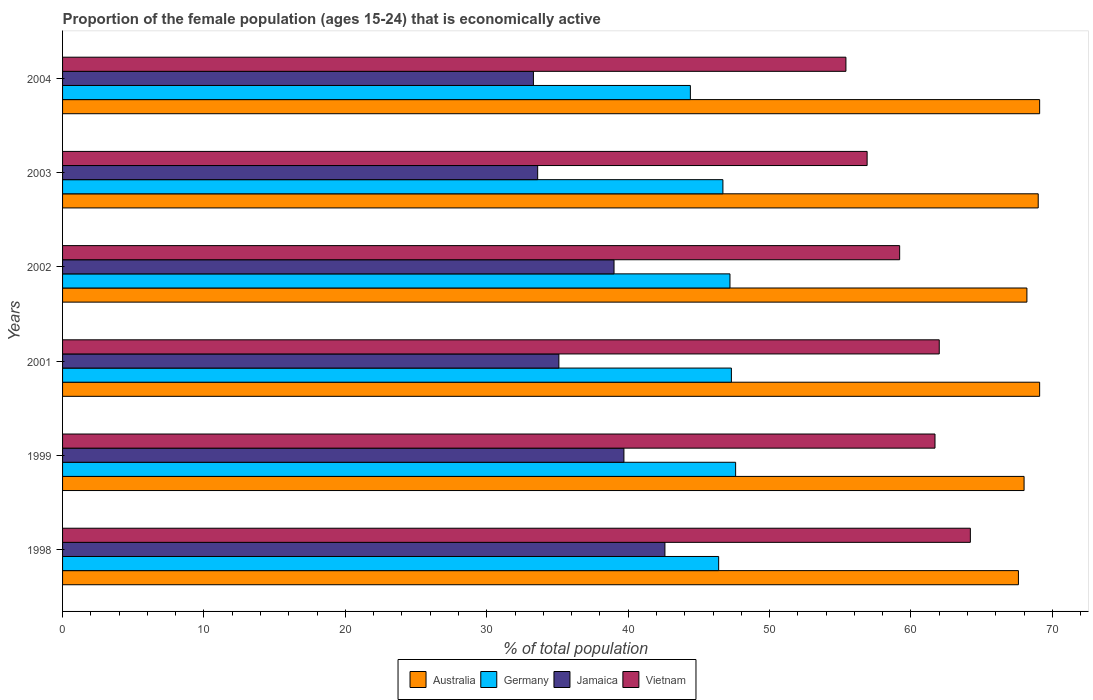How many different coloured bars are there?
Offer a very short reply. 4. How many groups of bars are there?
Your response must be concise. 6. Are the number of bars per tick equal to the number of legend labels?
Make the answer very short. Yes. Are the number of bars on each tick of the Y-axis equal?
Your response must be concise. Yes. How many bars are there on the 6th tick from the bottom?
Provide a short and direct response. 4. What is the proportion of the female population that is economically active in Australia in 2004?
Give a very brief answer. 69.1. Across all years, what is the maximum proportion of the female population that is economically active in Australia?
Your answer should be compact. 69.1. Across all years, what is the minimum proportion of the female population that is economically active in Australia?
Your response must be concise. 67.6. In which year was the proportion of the female population that is economically active in Germany maximum?
Offer a very short reply. 1999. In which year was the proportion of the female population that is economically active in Jamaica minimum?
Make the answer very short. 2004. What is the total proportion of the female population that is economically active in Jamaica in the graph?
Your answer should be very brief. 223.3. What is the difference between the proportion of the female population that is economically active in Vietnam in 1998 and the proportion of the female population that is economically active in Australia in 2001?
Make the answer very short. -4.9. What is the average proportion of the female population that is economically active in Australia per year?
Your answer should be very brief. 68.5. In the year 2003, what is the difference between the proportion of the female population that is economically active in Germany and proportion of the female population that is economically active in Vietnam?
Your answer should be compact. -10.2. What is the ratio of the proportion of the female population that is economically active in Germany in 1998 to that in 2003?
Offer a very short reply. 0.99. Is the proportion of the female population that is economically active in Vietnam in 1999 less than that in 2001?
Your answer should be very brief. Yes. Is the difference between the proportion of the female population that is economically active in Germany in 2001 and 2004 greater than the difference between the proportion of the female population that is economically active in Vietnam in 2001 and 2004?
Provide a short and direct response. No. What is the difference between the highest and the second highest proportion of the female population that is economically active in Vietnam?
Keep it short and to the point. 2.2. What is the difference between the highest and the lowest proportion of the female population that is economically active in Vietnam?
Offer a terse response. 8.8. In how many years, is the proportion of the female population that is economically active in Vietnam greater than the average proportion of the female population that is economically active in Vietnam taken over all years?
Your answer should be very brief. 3. Is the sum of the proportion of the female population that is economically active in Australia in 2001 and 2004 greater than the maximum proportion of the female population that is economically active in Jamaica across all years?
Your answer should be very brief. Yes. What does the 3rd bar from the top in 1999 represents?
Keep it short and to the point. Germany. Are all the bars in the graph horizontal?
Ensure brevity in your answer.  Yes. How many years are there in the graph?
Provide a short and direct response. 6. Does the graph contain any zero values?
Your answer should be compact. No. Does the graph contain grids?
Offer a very short reply. No. How are the legend labels stacked?
Give a very brief answer. Horizontal. What is the title of the graph?
Make the answer very short. Proportion of the female population (ages 15-24) that is economically active. What is the label or title of the X-axis?
Give a very brief answer. % of total population. What is the % of total population of Australia in 1998?
Offer a terse response. 67.6. What is the % of total population in Germany in 1998?
Offer a very short reply. 46.4. What is the % of total population in Jamaica in 1998?
Provide a short and direct response. 42.6. What is the % of total population in Vietnam in 1998?
Provide a succinct answer. 64.2. What is the % of total population of Australia in 1999?
Your answer should be very brief. 68. What is the % of total population in Germany in 1999?
Offer a very short reply. 47.6. What is the % of total population of Jamaica in 1999?
Ensure brevity in your answer.  39.7. What is the % of total population of Vietnam in 1999?
Your answer should be compact. 61.7. What is the % of total population of Australia in 2001?
Offer a very short reply. 69.1. What is the % of total population in Germany in 2001?
Offer a terse response. 47.3. What is the % of total population in Jamaica in 2001?
Keep it short and to the point. 35.1. What is the % of total population in Vietnam in 2001?
Provide a succinct answer. 62. What is the % of total population of Australia in 2002?
Ensure brevity in your answer.  68.2. What is the % of total population of Germany in 2002?
Keep it short and to the point. 47.2. What is the % of total population in Jamaica in 2002?
Give a very brief answer. 39. What is the % of total population in Vietnam in 2002?
Your answer should be very brief. 59.2. What is the % of total population in Australia in 2003?
Ensure brevity in your answer.  69. What is the % of total population of Germany in 2003?
Your answer should be very brief. 46.7. What is the % of total population of Jamaica in 2003?
Your answer should be compact. 33.6. What is the % of total population in Vietnam in 2003?
Ensure brevity in your answer.  56.9. What is the % of total population in Australia in 2004?
Offer a terse response. 69.1. What is the % of total population of Germany in 2004?
Provide a succinct answer. 44.4. What is the % of total population in Jamaica in 2004?
Offer a very short reply. 33.3. What is the % of total population in Vietnam in 2004?
Make the answer very short. 55.4. Across all years, what is the maximum % of total population in Australia?
Make the answer very short. 69.1. Across all years, what is the maximum % of total population in Germany?
Offer a terse response. 47.6. Across all years, what is the maximum % of total population in Jamaica?
Offer a very short reply. 42.6. Across all years, what is the maximum % of total population of Vietnam?
Your answer should be compact. 64.2. Across all years, what is the minimum % of total population of Australia?
Make the answer very short. 67.6. Across all years, what is the minimum % of total population in Germany?
Make the answer very short. 44.4. Across all years, what is the minimum % of total population of Jamaica?
Ensure brevity in your answer.  33.3. Across all years, what is the minimum % of total population of Vietnam?
Your answer should be very brief. 55.4. What is the total % of total population in Australia in the graph?
Offer a terse response. 411. What is the total % of total population in Germany in the graph?
Provide a short and direct response. 279.6. What is the total % of total population of Jamaica in the graph?
Make the answer very short. 223.3. What is the total % of total population of Vietnam in the graph?
Your response must be concise. 359.4. What is the difference between the % of total population of Germany in 1998 and that in 1999?
Provide a short and direct response. -1.2. What is the difference between the % of total population of Jamaica in 1998 and that in 1999?
Your answer should be compact. 2.9. What is the difference between the % of total population in Australia in 1998 and that in 2002?
Offer a very short reply. -0.6. What is the difference between the % of total population in Germany in 1998 and that in 2002?
Your response must be concise. -0.8. What is the difference between the % of total population in Jamaica in 1998 and that in 2002?
Make the answer very short. 3.6. What is the difference between the % of total population of Germany in 1998 and that in 2003?
Provide a short and direct response. -0.3. What is the difference between the % of total population of Germany in 1998 and that in 2004?
Offer a terse response. 2. What is the difference between the % of total population of Jamaica in 1998 and that in 2004?
Offer a very short reply. 9.3. What is the difference between the % of total population of Australia in 1999 and that in 2001?
Make the answer very short. -1.1. What is the difference between the % of total population in Jamaica in 1999 and that in 2001?
Keep it short and to the point. 4.6. What is the difference between the % of total population in Vietnam in 1999 and that in 2001?
Offer a very short reply. -0.3. What is the difference between the % of total population of Australia in 1999 and that in 2002?
Your response must be concise. -0.2. What is the difference between the % of total population in Jamaica in 1999 and that in 2002?
Your answer should be very brief. 0.7. What is the difference between the % of total population in Vietnam in 1999 and that in 2002?
Your answer should be compact. 2.5. What is the difference between the % of total population of Australia in 1999 and that in 2003?
Provide a succinct answer. -1. What is the difference between the % of total population in Germany in 1999 and that in 2003?
Provide a short and direct response. 0.9. What is the difference between the % of total population of Jamaica in 1999 and that in 2003?
Offer a terse response. 6.1. What is the difference between the % of total population of Australia in 1999 and that in 2004?
Your answer should be compact. -1.1. What is the difference between the % of total population of Germany in 1999 and that in 2004?
Offer a terse response. 3.2. What is the difference between the % of total population of Jamaica in 1999 and that in 2004?
Your response must be concise. 6.4. What is the difference between the % of total population of Jamaica in 2001 and that in 2002?
Your response must be concise. -3.9. What is the difference between the % of total population of Vietnam in 2001 and that in 2002?
Offer a very short reply. 2.8. What is the difference between the % of total population of Germany in 2001 and that in 2003?
Your answer should be very brief. 0.6. What is the difference between the % of total population in Jamaica in 2001 and that in 2003?
Offer a terse response. 1.5. What is the difference between the % of total population in Australia in 2001 and that in 2004?
Offer a terse response. 0. What is the difference between the % of total population in Germany in 2001 and that in 2004?
Make the answer very short. 2.9. What is the difference between the % of total population in Jamaica in 2001 and that in 2004?
Ensure brevity in your answer.  1.8. What is the difference between the % of total population in Vietnam in 2001 and that in 2004?
Give a very brief answer. 6.6. What is the difference between the % of total population of Australia in 2002 and that in 2003?
Offer a terse response. -0.8. What is the difference between the % of total population in Germany in 2002 and that in 2003?
Provide a succinct answer. 0.5. What is the difference between the % of total population in Jamaica in 2002 and that in 2003?
Your response must be concise. 5.4. What is the difference between the % of total population of Australia in 2002 and that in 2004?
Offer a very short reply. -0.9. What is the difference between the % of total population of Australia in 2003 and that in 2004?
Offer a terse response. -0.1. What is the difference between the % of total population in Jamaica in 2003 and that in 2004?
Provide a succinct answer. 0.3. What is the difference between the % of total population of Vietnam in 2003 and that in 2004?
Ensure brevity in your answer.  1.5. What is the difference between the % of total population in Australia in 1998 and the % of total population in Germany in 1999?
Keep it short and to the point. 20. What is the difference between the % of total population of Australia in 1998 and the % of total population of Jamaica in 1999?
Make the answer very short. 27.9. What is the difference between the % of total population of Germany in 1998 and the % of total population of Vietnam in 1999?
Provide a succinct answer. -15.3. What is the difference between the % of total population in Jamaica in 1998 and the % of total population in Vietnam in 1999?
Offer a terse response. -19.1. What is the difference between the % of total population in Australia in 1998 and the % of total population in Germany in 2001?
Keep it short and to the point. 20.3. What is the difference between the % of total population in Australia in 1998 and the % of total population in Jamaica in 2001?
Your answer should be very brief. 32.5. What is the difference between the % of total population in Germany in 1998 and the % of total population in Jamaica in 2001?
Offer a very short reply. 11.3. What is the difference between the % of total population of Germany in 1998 and the % of total population of Vietnam in 2001?
Provide a short and direct response. -15.6. What is the difference between the % of total population of Jamaica in 1998 and the % of total population of Vietnam in 2001?
Provide a short and direct response. -19.4. What is the difference between the % of total population in Australia in 1998 and the % of total population in Germany in 2002?
Give a very brief answer. 20.4. What is the difference between the % of total population of Australia in 1998 and the % of total population of Jamaica in 2002?
Provide a short and direct response. 28.6. What is the difference between the % of total population of Australia in 1998 and the % of total population of Vietnam in 2002?
Offer a very short reply. 8.4. What is the difference between the % of total population of Germany in 1998 and the % of total population of Jamaica in 2002?
Your answer should be compact. 7.4. What is the difference between the % of total population of Jamaica in 1998 and the % of total population of Vietnam in 2002?
Your response must be concise. -16.6. What is the difference between the % of total population in Australia in 1998 and the % of total population in Germany in 2003?
Give a very brief answer. 20.9. What is the difference between the % of total population in Australia in 1998 and the % of total population in Jamaica in 2003?
Offer a terse response. 34. What is the difference between the % of total population in Germany in 1998 and the % of total population in Jamaica in 2003?
Give a very brief answer. 12.8. What is the difference between the % of total population in Jamaica in 1998 and the % of total population in Vietnam in 2003?
Ensure brevity in your answer.  -14.3. What is the difference between the % of total population of Australia in 1998 and the % of total population of Germany in 2004?
Offer a very short reply. 23.2. What is the difference between the % of total population of Australia in 1998 and the % of total population of Jamaica in 2004?
Keep it short and to the point. 34.3. What is the difference between the % of total population of Australia in 1998 and the % of total population of Vietnam in 2004?
Offer a very short reply. 12.2. What is the difference between the % of total population of Jamaica in 1998 and the % of total population of Vietnam in 2004?
Your response must be concise. -12.8. What is the difference between the % of total population of Australia in 1999 and the % of total population of Germany in 2001?
Keep it short and to the point. 20.7. What is the difference between the % of total population of Australia in 1999 and the % of total population of Jamaica in 2001?
Offer a very short reply. 32.9. What is the difference between the % of total population of Germany in 1999 and the % of total population of Vietnam in 2001?
Your response must be concise. -14.4. What is the difference between the % of total population of Jamaica in 1999 and the % of total population of Vietnam in 2001?
Keep it short and to the point. -22.3. What is the difference between the % of total population in Australia in 1999 and the % of total population in Germany in 2002?
Provide a succinct answer. 20.8. What is the difference between the % of total population of Australia in 1999 and the % of total population of Jamaica in 2002?
Keep it short and to the point. 29. What is the difference between the % of total population of Australia in 1999 and the % of total population of Vietnam in 2002?
Your answer should be compact. 8.8. What is the difference between the % of total population in Germany in 1999 and the % of total population in Jamaica in 2002?
Provide a succinct answer. 8.6. What is the difference between the % of total population of Germany in 1999 and the % of total population of Vietnam in 2002?
Provide a short and direct response. -11.6. What is the difference between the % of total population in Jamaica in 1999 and the % of total population in Vietnam in 2002?
Keep it short and to the point. -19.5. What is the difference between the % of total population of Australia in 1999 and the % of total population of Germany in 2003?
Offer a very short reply. 21.3. What is the difference between the % of total population in Australia in 1999 and the % of total population in Jamaica in 2003?
Ensure brevity in your answer.  34.4. What is the difference between the % of total population of Germany in 1999 and the % of total population of Jamaica in 2003?
Provide a short and direct response. 14. What is the difference between the % of total population of Jamaica in 1999 and the % of total population of Vietnam in 2003?
Provide a succinct answer. -17.2. What is the difference between the % of total population in Australia in 1999 and the % of total population in Germany in 2004?
Ensure brevity in your answer.  23.6. What is the difference between the % of total population in Australia in 1999 and the % of total population in Jamaica in 2004?
Your answer should be compact. 34.7. What is the difference between the % of total population of Australia in 1999 and the % of total population of Vietnam in 2004?
Your answer should be compact. 12.6. What is the difference between the % of total population of Germany in 1999 and the % of total population of Jamaica in 2004?
Your answer should be very brief. 14.3. What is the difference between the % of total population of Germany in 1999 and the % of total population of Vietnam in 2004?
Keep it short and to the point. -7.8. What is the difference between the % of total population of Jamaica in 1999 and the % of total population of Vietnam in 2004?
Give a very brief answer. -15.7. What is the difference between the % of total population of Australia in 2001 and the % of total population of Germany in 2002?
Your response must be concise. 21.9. What is the difference between the % of total population of Australia in 2001 and the % of total population of Jamaica in 2002?
Give a very brief answer. 30.1. What is the difference between the % of total population in Australia in 2001 and the % of total population in Vietnam in 2002?
Offer a terse response. 9.9. What is the difference between the % of total population of Germany in 2001 and the % of total population of Jamaica in 2002?
Provide a short and direct response. 8.3. What is the difference between the % of total population of Germany in 2001 and the % of total population of Vietnam in 2002?
Provide a short and direct response. -11.9. What is the difference between the % of total population in Jamaica in 2001 and the % of total population in Vietnam in 2002?
Offer a very short reply. -24.1. What is the difference between the % of total population in Australia in 2001 and the % of total population in Germany in 2003?
Give a very brief answer. 22.4. What is the difference between the % of total population in Australia in 2001 and the % of total population in Jamaica in 2003?
Give a very brief answer. 35.5. What is the difference between the % of total population of Jamaica in 2001 and the % of total population of Vietnam in 2003?
Your answer should be compact. -21.8. What is the difference between the % of total population of Australia in 2001 and the % of total population of Germany in 2004?
Your answer should be compact. 24.7. What is the difference between the % of total population in Australia in 2001 and the % of total population in Jamaica in 2004?
Provide a succinct answer. 35.8. What is the difference between the % of total population of Germany in 2001 and the % of total population of Jamaica in 2004?
Keep it short and to the point. 14. What is the difference between the % of total population in Jamaica in 2001 and the % of total population in Vietnam in 2004?
Offer a very short reply. -20.3. What is the difference between the % of total population of Australia in 2002 and the % of total population of Germany in 2003?
Make the answer very short. 21.5. What is the difference between the % of total population in Australia in 2002 and the % of total population in Jamaica in 2003?
Your answer should be very brief. 34.6. What is the difference between the % of total population of Australia in 2002 and the % of total population of Vietnam in 2003?
Offer a terse response. 11.3. What is the difference between the % of total population of Germany in 2002 and the % of total population of Vietnam in 2003?
Give a very brief answer. -9.7. What is the difference between the % of total population in Jamaica in 2002 and the % of total population in Vietnam in 2003?
Ensure brevity in your answer.  -17.9. What is the difference between the % of total population in Australia in 2002 and the % of total population in Germany in 2004?
Your answer should be compact. 23.8. What is the difference between the % of total population in Australia in 2002 and the % of total population in Jamaica in 2004?
Provide a succinct answer. 34.9. What is the difference between the % of total population of Germany in 2002 and the % of total population of Vietnam in 2004?
Offer a very short reply. -8.2. What is the difference between the % of total population in Jamaica in 2002 and the % of total population in Vietnam in 2004?
Provide a succinct answer. -16.4. What is the difference between the % of total population in Australia in 2003 and the % of total population in Germany in 2004?
Offer a terse response. 24.6. What is the difference between the % of total population in Australia in 2003 and the % of total population in Jamaica in 2004?
Make the answer very short. 35.7. What is the difference between the % of total population of Australia in 2003 and the % of total population of Vietnam in 2004?
Ensure brevity in your answer.  13.6. What is the difference between the % of total population in Germany in 2003 and the % of total population in Jamaica in 2004?
Your answer should be very brief. 13.4. What is the difference between the % of total population in Jamaica in 2003 and the % of total population in Vietnam in 2004?
Make the answer very short. -21.8. What is the average % of total population of Australia per year?
Provide a succinct answer. 68.5. What is the average % of total population of Germany per year?
Your answer should be very brief. 46.6. What is the average % of total population in Jamaica per year?
Your response must be concise. 37.22. What is the average % of total population of Vietnam per year?
Provide a short and direct response. 59.9. In the year 1998, what is the difference between the % of total population of Australia and % of total population of Germany?
Ensure brevity in your answer.  21.2. In the year 1998, what is the difference between the % of total population in Australia and % of total population in Vietnam?
Offer a very short reply. 3.4. In the year 1998, what is the difference between the % of total population of Germany and % of total population of Jamaica?
Your response must be concise. 3.8. In the year 1998, what is the difference between the % of total population of Germany and % of total population of Vietnam?
Ensure brevity in your answer.  -17.8. In the year 1998, what is the difference between the % of total population in Jamaica and % of total population in Vietnam?
Give a very brief answer. -21.6. In the year 1999, what is the difference between the % of total population in Australia and % of total population in Germany?
Offer a terse response. 20.4. In the year 1999, what is the difference between the % of total population in Australia and % of total population in Jamaica?
Offer a terse response. 28.3. In the year 1999, what is the difference between the % of total population of Australia and % of total population of Vietnam?
Provide a succinct answer. 6.3. In the year 1999, what is the difference between the % of total population in Germany and % of total population in Jamaica?
Your response must be concise. 7.9. In the year 1999, what is the difference between the % of total population in Germany and % of total population in Vietnam?
Offer a terse response. -14.1. In the year 1999, what is the difference between the % of total population of Jamaica and % of total population of Vietnam?
Provide a succinct answer. -22. In the year 2001, what is the difference between the % of total population in Australia and % of total population in Germany?
Offer a terse response. 21.8. In the year 2001, what is the difference between the % of total population of Germany and % of total population of Jamaica?
Ensure brevity in your answer.  12.2. In the year 2001, what is the difference between the % of total population of Germany and % of total population of Vietnam?
Keep it short and to the point. -14.7. In the year 2001, what is the difference between the % of total population in Jamaica and % of total population in Vietnam?
Your answer should be very brief. -26.9. In the year 2002, what is the difference between the % of total population in Australia and % of total population in Germany?
Ensure brevity in your answer.  21. In the year 2002, what is the difference between the % of total population of Australia and % of total population of Jamaica?
Offer a terse response. 29.2. In the year 2002, what is the difference between the % of total population of Australia and % of total population of Vietnam?
Provide a succinct answer. 9. In the year 2002, what is the difference between the % of total population in Germany and % of total population in Vietnam?
Provide a short and direct response. -12. In the year 2002, what is the difference between the % of total population of Jamaica and % of total population of Vietnam?
Your answer should be very brief. -20.2. In the year 2003, what is the difference between the % of total population of Australia and % of total population of Germany?
Ensure brevity in your answer.  22.3. In the year 2003, what is the difference between the % of total population in Australia and % of total population in Jamaica?
Provide a succinct answer. 35.4. In the year 2003, what is the difference between the % of total population of Germany and % of total population of Jamaica?
Your response must be concise. 13.1. In the year 2003, what is the difference between the % of total population in Germany and % of total population in Vietnam?
Your answer should be very brief. -10.2. In the year 2003, what is the difference between the % of total population of Jamaica and % of total population of Vietnam?
Offer a terse response. -23.3. In the year 2004, what is the difference between the % of total population of Australia and % of total population of Germany?
Your answer should be compact. 24.7. In the year 2004, what is the difference between the % of total population of Australia and % of total population of Jamaica?
Your answer should be very brief. 35.8. In the year 2004, what is the difference between the % of total population in Australia and % of total population in Vietnam?
Your response must be concise. 13.7. In the year 2004, what is the difference between the % of total population of Jamaica and % of total population of Vietnam?
Make the answer very short. -22.1. What is the ratio of the % of total population in Germany in 1998 to that in 1999?
Ensure brevity in your answer.  0.97. What is the ratio of the % of total population in Jamaica in 1998 to that in 1999?
Your response must be concise. 1.07. What is the ratio of the % of total population in Vietnam in 1998 to that in 1999?
Your answer should be compact. 1.04. What is the ratio of the % of total population in Australia in 1998 to that in 2001?
Your answer should be very brief. 0.98. What is the ratio of the % of total population of Germany in 1998 to that in 2001?
Your answer should be compact. 0.98. What is the ratio of the % of total population of Jamaica in 1998 to that in 2001?
Your answer should be very brief. 1.21. What is the ratio of the % of total population of Vietnam in 1998 to that in 2001?
Make the answer very short. 1.04. What is the ratio of the % of total population of Germany in 1998 to that in 2002?
Offer a very short reply. 0.98. What is the ratio of the % of total population in Jamaica in 1998 to that in 2002?
Make the answer very short. 1.09. What is the ratio of the % of total population in Vietnam in 1998 to that in 2002?
Give a very brief answer. 1.08. What is the ratio of the % of total population of Australia in 1998 to that in 2003?
Provide a succinct answer. 0.98. What is the ratio of the % of total population in Jamaica in 1998 to that in 2003?
Give a very brief answer. 1.27. What is the ratio of the % of total population in Vietnam in 1998 to that in 2003?
Give a very brief answer. 1.13. What is the ratio of the % of total population in Australia in 1998 to that in 2004?
Your answer should be compact. 0.98. What is the ratio of the % of total population of Germany in 1998 to that in 2004?
Provide a succinct answer. 1.04. What is the ratio of the % of total population of Jamaica in 1998 to that in 2004?
Give a very brief answer. 1.28. What is the ratio of the % of total population of Vietnam in 1998 to that in 2004?
Provide a short and direct response. 1.16. What is the ratio of the % of total population of Australia in 1999 to that in 2001?
Offer a very short reply. 0.98. What is the ratio of the % of total population in Jamaica in 1999 to that in 2001?
Offer a terse response. 1.13. What is the ratio of the % of total population of Vietnam in 1999 to that in 2001?
Offer a terse response. 1. What is the ratio of the % of total population of Germany in 1999 to that in 2002?
Provide a succinct answer. 1.01. What is the ratio of the % of total population of Jamaica in 1999 to that in 2002?
Offer a very short reply. 1.02. What is the ratio of the % of total population in Vietnam in 1999 to that in 2002?
Keep it short and to the point. 1.04. What is the ratio of the % of total population in Australia in 1999 to that in 2003?
Provide a succinct answer. 0.99. What is the ratio of the % of total population of Germany in 1999 to that in 2003?
Your response must be concise. 1.02. What is the ratio of the % of total population in Jamaica in 1999 to that in 2003?
Provide a short and direct response. 1.18. What is the ratio of the % of total population in Vietnam in 1999 to that in 2003?
Keep it short and to the point. 1.08. What is the ratio of the % of total population of Australia in 1999 to that in 2004?
Provide a short and direct response. 0.98. What is the ratio of the % of total population of Germany in 1999 to that in 2004?
Your answer should be very brief. 1.07. What is the ratio of the % of total population of Jamaica in 1999 to that in 2004?
Offer a terse response. 1.19. What is the ratio of the % of total population of Vietnam in 1999 to that in 2004?
Your answer should be very brief. 1.11. What is the ratio of the % of total population of Australia in 2001 to that in 2002?
Offer a very short reply. 1.01. What is the ratio of the % of total population of Jamaica in 2001 to that in 2002?
Provide a short and direct response. 0.9. What is the ratio of the % of total population of Vietnam in 2001 to that in 2002?
Provide a short and direct response. 1.05. What is the ratio of the % of total population in Germany in 2001 to that in 2003?
Give a very brief answer. 1.01. What is the ratio of the % of total population of Jamaica in 2001 to that in 2003?
Keep it short and to the point. 1.04. What is the ratio of the % of total population in Vietnam in 2001 to that in 2003?
Ensure brevity in your answer.  1.09. What is the ratio of the % of total population of Germany in 2001 to that in 2004?
Keep it short and to the point. 1.07. What is the ratio of the % of total population in Jamaica in 2001 to that in 2004?
Keep it short and to the point. 1.05. What is the ratio of the % of total population in Vietnam in 2001 to that in 2004?
Keep it short and to the point. 1.12. What is the ratio of the % of total population in Australia in 2002 to that in 2003?
Your answer should be compact. 0.99. What is the ratio of the % of total population of Germany in 2002 to that in 2003?
Provide a succinct answer. 1.01. What is the ratio of the % of total population of Jamaica in 2002 to that in 2003?
Provide a short and direct response. 1.16. What is the ratio of the % of total population in Vietnam in 2002 to that in 2003?
Your response must be concise. 1.04. What is the ratio of the % of total population of Australia in 2002 to that in 2004?
Provide a short and direct response. 0.99. What is the ratio of the % of total population in Germany in 2002 to that in 2004?
Offer a terse response. 1.06. What is the ratio of the % of total population of Jamaica in 2002 to that in 2004?
Your answer should be compact. 1.17. What is the ratio of the % of total population of Vietnam in 2002 to that in 2004?
Your answer should be compact. 1.07. What is the ratio of the % of total population of Germany in 2003 to that in 2004?
Ensure brevity in your answer.  1.05. What is the ratio of the % of total population of Vietnam in 2003 to that in 2004?
Offer a terse response. 1.03. What is the difference between the highest and the second highest % of total population in Vietnam?
Keep it short and to the point. 2.2. What is the difference between the highest and the lowest % of total population in Australia?
Give a very brief answer. 1.5. What is the difference between the highest and the lowest % of total population in Jamaica?
Offer a terse response. 9.3. 